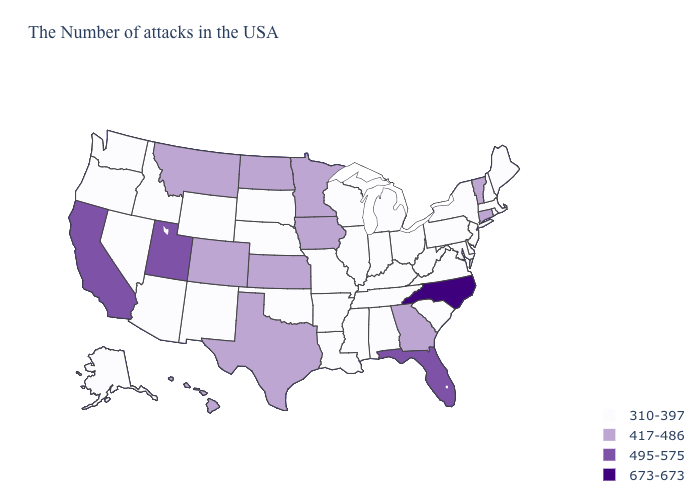What is the highest value in the USA?
Concise answer only. 673-673. Name the states that have a value in the range 310-397?
Short answer required. Maine, Massachusetts, Rhode Island, New Hampshire, New York, New Jersey, Delaware, Maryland, Pennsylvania, Virginia, South Carolina, West Virginia, Ohio, Michigan, Kentucky, Indiana, Alabama, Tennessee, Wisconsin, Illinois, Mississippi, Louisiana, Missouri, Arkansas, Nebraska, Oklahoma, South Dakota, Wyoming, New Mexico, Arizona, Idaho, Nevada, Washington, Oregon, Alaska. What is the lowest value in the USA?
Short answer required. 310-397. Name the states that have a value in the range 495-575?
Give a very brief answer. Florida, Utah, California. Among the states that border New York , which have the highest value?
Keep it brief. Vermont, Connecticut. What is the highest value in the MidWest ?
Short answer required. 417-486. Name the states that have a value in the range 495-575?
Write a very short answer. Florida, Utah, California. What is the value of Nebraska?
Quick response, please. 310-397. Which states hav the highest value in the Northeast?
Be succinct. Vermont, Connecticut. What is the value of Nevada?
Quick response, please. 310-397. Is the legend a continuous bar?
Concise answer only. No. Does the map have missing data?
Quick response, please. No. Does Minnesota have the lowest value in the USA?
Concise answer only. No. What is the value of Massachusetts?
Give a very brief answer. 310-397. 